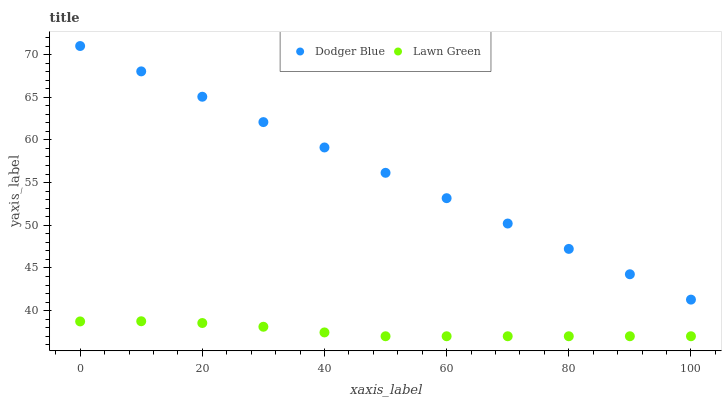Does Lawn Green have the minimum area under the curve?
Answer yes or no. Yes. Does Dodger Blue have the maximum area under the curve?
Answer yes or no. Yes. Does Dodger Blue have the minimum area under the curve?
Answer yes or no. No. Is Dodger Blue the smoothest?
Answer yes or no. Yes. Is Lawn Green the roughest?
Answer yes or no. Yes. Is Dodger Blue the roughest?
Answer yes or no. No. Does Lawn Green have the lowest value?
Answer yes or no. Yes. Does Dodger Blue have the lowest value?
Answer yes or no. No. Does Dodger Blue have the highest value?
Answer yes or no. Yes. Is Lawn Green less than Dodger Blue?
Answer yes or no. Yes. Is Dodger Blue greater than Lawn Green?
Answer yes or no. Yes. Does Lawn Green intersect Dodger Blue?
Answer yes or no. No. 